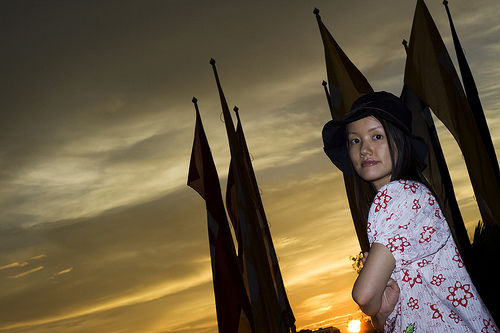<image>
Is the woman behind the flag? No. The woman is not behind the flag. From this viewpoint, the woman appears to be positioned elsewhere in the scene. Where is the young girl in relation to the flag pole? Is it behind the flag pole? No. The young girl is not behind the flag pole. From this viewpoint, the young girl appears to be positioned elsewhere in the scene. Is there a girl in front of the flag? Yes. The girl is positioned in front of the flag, appearing closer to the camera viewpoint. 